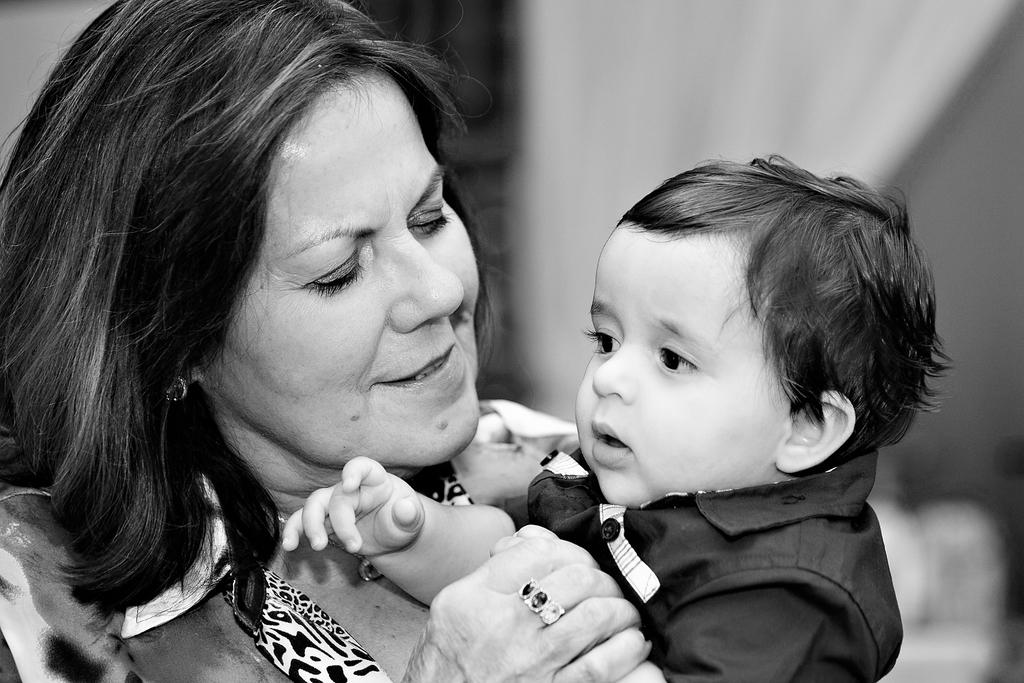Who is the main subject in the image? There is a lady in the image. Can you describe the other person in the image? There is a small baby in the image. Where are the lady and the baby located in the image? The lady and the baby are in the center of the image. What is the appearance of the background in the image? The background of the image is blurred. What type of veil is the lady wearing in the image? There is no veil present in the image. How many cars can be seen in the background of the image? There are no cars visible in the image, as the background is blurred. 